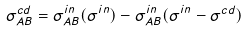Convert formula to latex. <formula><loc_0><loc_0><loc_500><loc_500>\sigma _ { A B } ^ { c d } = \sigma _ { A B } ^ { i n } ( \sigma ^ { i n } ) - \sigma _ { A B } ^ { i n } ( \sigma ^ { i n } - \sigma ^ { c d } )</formula> 